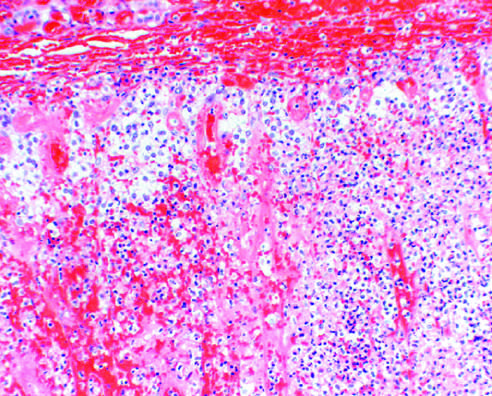what were grossly hemorrhagic and shrunken at autopsy?
Answer the question using a single word or phrase. The adrenal glands 